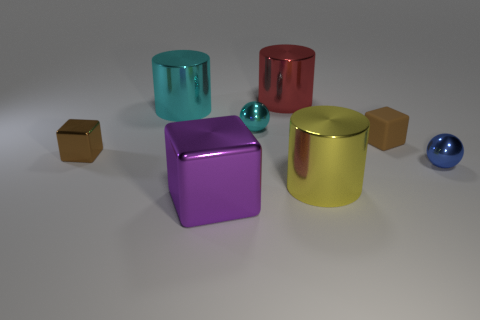Are there fewer metallic cubes in front of the tiny blue shiny object than large cyan shiny objects to the right of the cyan metallic ball?
Provide a short and direct response. No. What color is the large thing that is the same shape as the tiny matte object?
Offer a very short reply. Purple. Does the yellow metal thing have the same shape as the tiny thing to the left of the tiny cyan ball?
Provide a short and direct response. No. What number of things are big cylinders that are in front of the big red metal cylinder or shiny cubes behind the blue ball?
Your answer should be very brief. 3. How many other things are there of the same size as the blue metallic object?
Ensure brevity in your answer.  3. What is the size of the yellow metal cylinder that is on the right side of the big red metallic cylinder?
Your response must be concise. Large. What is the material of the small block that is to the right of the cylinder that is in front of the cyan object that is to the right of the purple shiny cube?
Provide a succinct answer. Rubber. Is the small blue thing the same shape as the tiny cyan object?
Give a very brief answer. Yes. How many rubber things are either big blue objects or purple things?
Provide a succinct answer. 0. How many small red balls are there?
Your response must be concise. 0. 